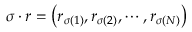<formula> <loc_0><loc_0><loc_500><loc_500>\sigma \cdot r = \left ( r _ { \sigma \left ( 1 \right ) } , r _ { \sigma \left ( 2 \right ) } , \cdots , r _ { \sigma \left ( N \right ) } \right )</formula> 